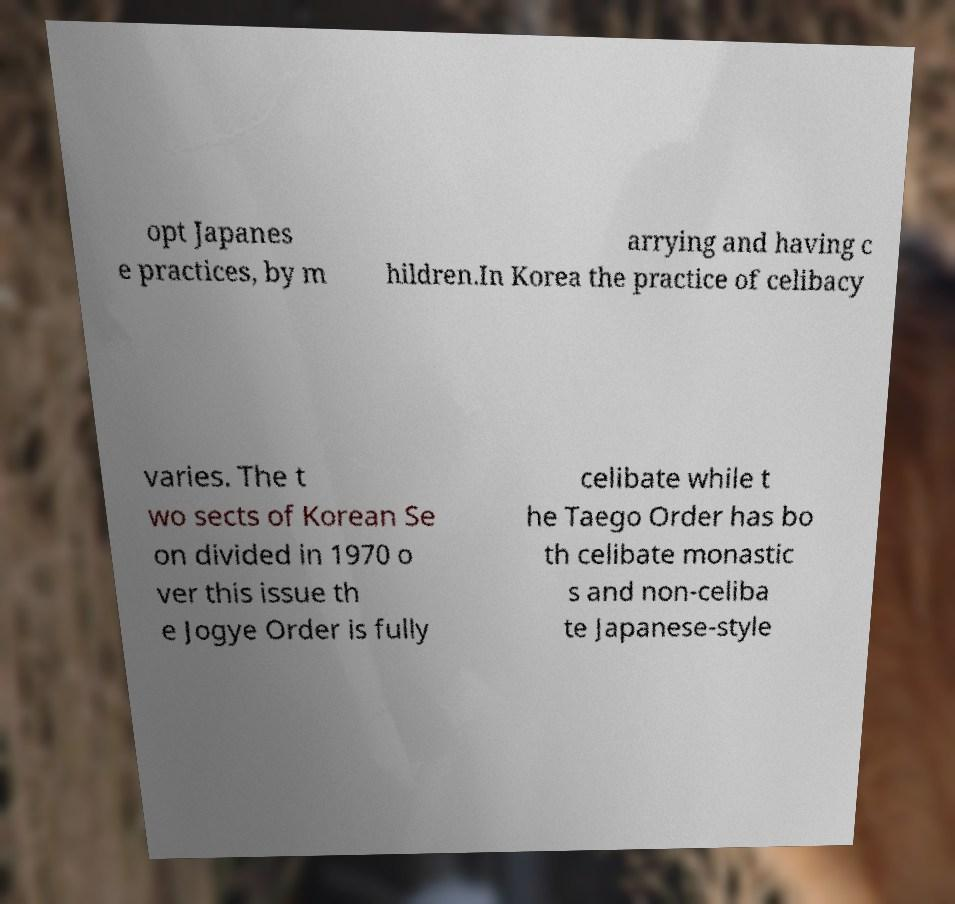There's text embedded in this image that I need extracted. Can you transcribe it verbatim? opt Japanes e practices, by m arrying and having c hildren.In Korea the practice of celibacy varies. The t wo sects of Korean Se on divided in 1970 o ver this issue th e Jogye Order is fully celibate while t he Taego Order has bo th celibate monastic s and non-celiba te Japanese-style 